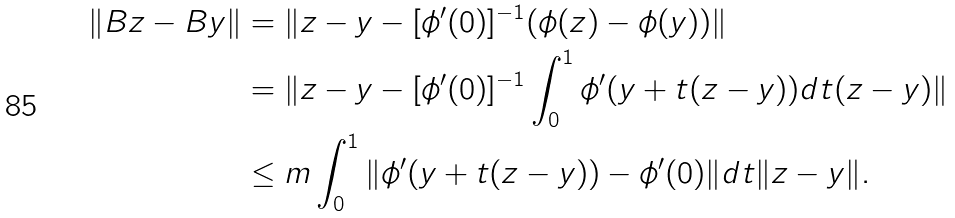Convert formula to latex. <formula><loc_0><loc_0><loc_500><loc_500>\| B z - B y \| & = \| z - y - [ \phi ^ { \prime } ( 0 ) ] ^ { - 1 } ( \phi ( z ) - \phi ( y ) ) \| \\ & = \| z - y - [ \phi ^ { \prime } ( 0 ) ] ^ { - 1 } \int _ { 0 } ^ { 1 } \phi ^ { \prime } ( y + t ( z - y ) ) d t ( z - y ) \| \\ & \leq m \int _ { 0 } ^ { 1 } \| \phi ^ { \prime } ( y + t ( z - y ) ) - \phi ^ { \prime } ( 0 ) \| d t \| z - y \| .</formula> 